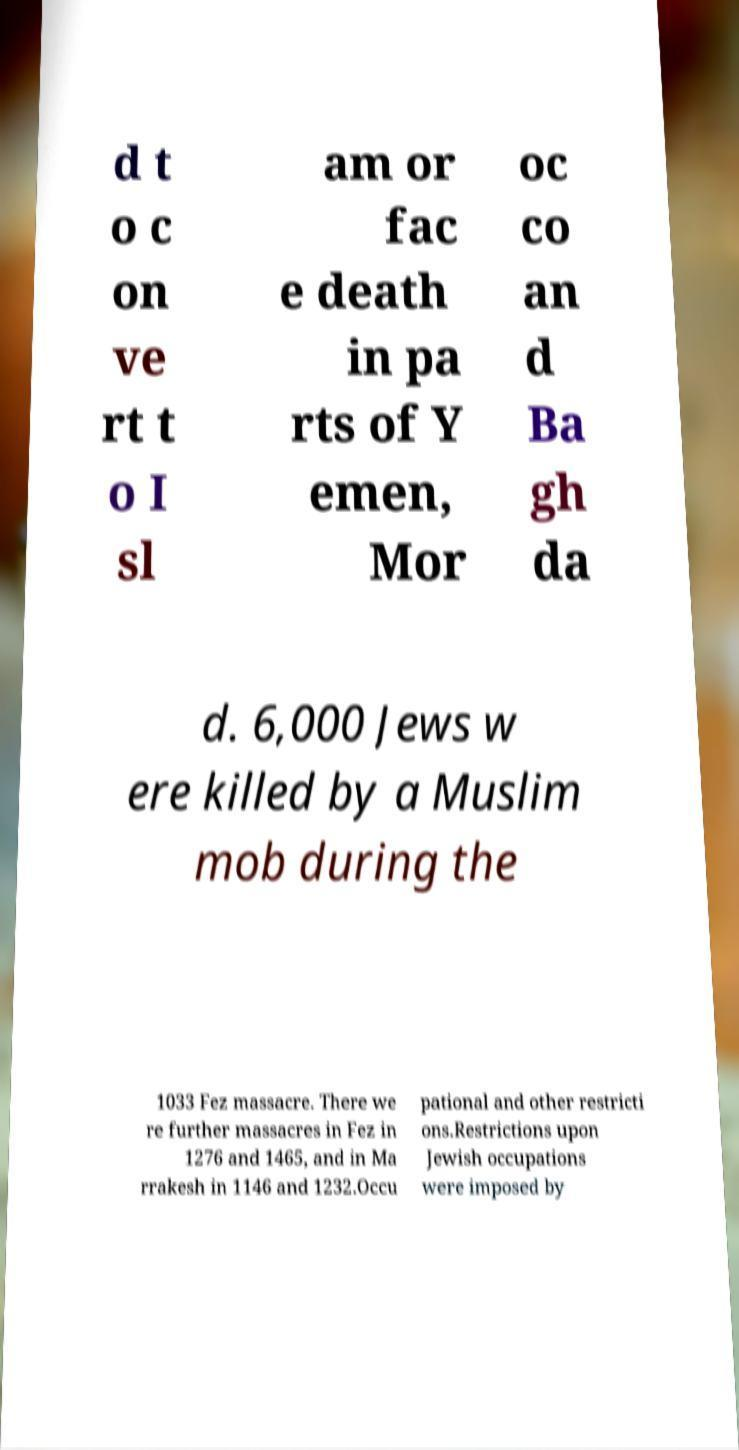Can you read and provide the text displayed in the image?This photo seems to have some interesting text. Can you extract and type it out for me? d t o c on ve rt t o I sl am or fac e death in pa rts of Y emen, Mor oc co an d Ba gh da d. 6,000 Jews w ere killed by a Muslim mob during the 1033 Fez massacre. There we re further massacres in Fez in 1276 and 1465, and in Ma rrakesh in 1146 and 1232.Occu pational and other restricti ons.Restrictions upon Jewish occupations were imposed by 